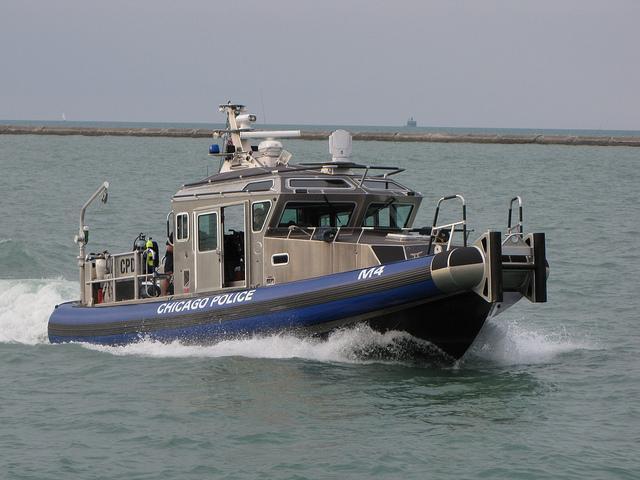How many birds are in the picture?
Give a very brief answer. 0. How many people are playing the game?
Give a very brief answer. 0. 